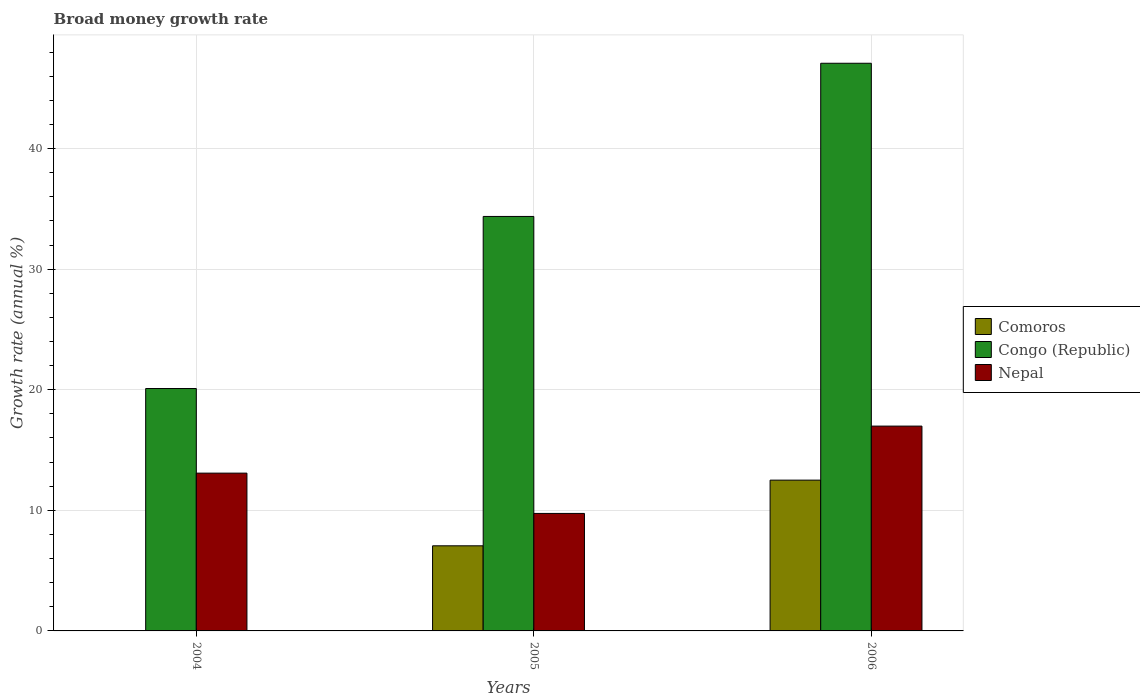Are the number of bars per tick equal to the number of legend labels?
Your answer should be very brief. No. In how many cases, is the number of bars for a given year not equal to the number of legend labels?
Your answer should be very brief. 1. Across all years, what is the maximum growth rate in Nepal?
Keep it short and to the point. 16.99. Across all years, what is the minimum growth rate in Nepal?
Provide a succinct answer. 9.74. What is the total growth rate in Congo (Republic) in the graph?
Offer a very short reply. 101.55. What is the difference between the growth rate in Nepal in 2005 and that in 2006?
Your response must be concise. -7.24. What is the difference between the growth rate in Nepal in 2005 and the growth rate in Congo (Republic) in 2004?
Ensure brevity in your answer.  -10.36. What is the average growth rate in Nepal per year?
Provide a short and direct response. 13.27. In the year 2006, what is the difference between the growth rate in Comoros and growth rate in Nepal?
Provide a short and direct response. -4.48. In how many years, is the growth rate in Nepal greater than 24 %?
Your answer should be very brief. 0. What is the ratio of the growth rate in Congo (Republic) in 2004 to that in 2005?
Ensure brevity in your answer.  0.58. Is the growth rate in Congo (Republic) in 2004 less than that in 2006?
Your answer should be very brief. Yes. What is the difference between the highest and the second highest growth rate in Nepal?
Give a very brief answer. 3.9. What is the difference between the highest and the lowest growth rate in Comoros?
Ensure brevity in your answer.  12.5. In how many years, is the growth rate in Congo (Republic) greater than the average growth rate in Congo (Republic) taken over all years?
Provide a short and direct response. 2. Is the sum of the growth rate in Congo (Republic) in 2004 and 2006 greater than the maximum growth rate in Nepal across all years?
Your answer should be very brief. Yes. How many bars are there?
Offer a very short reply. 8. Are all the bars in the graph horizontal?
Your answer should be compact. No. What is the difference between two consecutive major ticks on the Y-axis?
Your answer should be very brief. 10. Where does the legend appear in the graph?
Offer a terse response. Center right. What is the title of the graph?
Make the answer very short. Broad money growth rate. What is the label or title of the Y-axis?
Provide a short and direct response. Growth rate (annual %). What is the Growth rate (annual %) of Comoros in 2004?
Ensure brevity in your answer.  0. What is the Growth rate (annual %) of Congo (Republic) in 2004?
Your response must be concise. 20.1. What is the Growth rate (annual %) of Nepal in 2004?
Ensure brevity in your answer.  13.09. What is the Growth rate (annual %) of Comoros in 2005?
Make the answer very short. 7.06. What is the Growth rate (annual %) of Congo (Republic) in 2005?
Ensure brevity in your answer.  34.37. What is the Growth rate (annual %) in Nepal in 2005?
Give a very brief answer. 9.74. What is the Growth rate (annual %) of Comoros in 2006?
Make the answer very short. 12.5. What is the Growth rate (annual %) in Congo (Republic) in 2006?
Make the answer very short. 47.08. What is the Growth rate (annual %) of Nepal in 2006?
Make the answer very short. 16.99. Across all years, what is the maximum Growth rate (annual %) in Comoros?
Provide a short and direct response. 12.5. Across all years, what is the maximum Growth rate (annual %) of Congo (Republic)?
Provide a succinct answer. 47.08. Across all years, what is the maximum Growth rate (annual %) in Nepal?
Give a very brief answer. 16.99. Across all years, what is the minimum Growth rate (annual %) of Comoros?
Give a very brief answer. 0. Across all years, what is the minimum Growth rate (annual %) in Congo (Republic)?
Ensure brevity in your answer.  20.1. Across all years, what is the minimum Growth rate (annual %) of Nepal?
Your answer should be very brief. 9.74. What is the total Growth rate (annual %) of Comoros in the graph?
Make the answer very short. 19.56. What is the total Growth rate (annual %) of Congo (Republic) in the graph?
Your response must be concise. 101.55. What is the total Growth rate (annual %) of Nepal in the graph?
Keep it short and to the point. 39.81. What is the difference between the Growth rate (annual %) in Congo (Republic) in 2004 and that in 2005?
Your answer should be compact. -14.27. What is the difference between the Growth rate (annual %) in Nepal in 2004 and that in 2005?
Offer a terse response. 3.34. What is the difference between the Growth rate (annual %) in Congo (Republic) in 2004 and that in 2006?
Make the answer very short. -26.97. What is the difference between the Growth rate (annual %) in Nepal in 2004 and that in 2006?
Your answer should be very brief. -3.9. What is the difference between the Growth rate (annual %) of Comoros in 2005 and that in 2006?
Provide a short and direct response. -5.45. What is the difference between the Growth rate (annual %) in Congo (Republic) in 2005 and that in 2006?
Your answer should be compact. -12.7. What is the difference between the Growth rate (annual %) in Nepal in 2005 and that in 2006?
Ensure brevity in your answer.  -7.24. What is the difference between the Growth rate (annual %) of Congo (Republic) in 2004 and the Growth rate (annual %) of Nepal in 2005?
Offer a very short reply. 10.36. What is the difference between the Growth rate (annual %) of Congo (Republic) in 2004 and the Growth rate (annual %) of Nepal in 2006?
Your answer should be compact. 3.12. What is the difference between the Growth rate (annual %) of Comoros in 2005 and the Growth rate (annual %) of Congo (Republic) in 2006?
Offer a very short reply. -40.02. What is the difference between the Growth rate (annual %) in Comoros in 2005 and the Growth rate (annual %) in Nepal in 2006?
Give a very brief answer. -9.93. What is the difference between the Growth rate (annual %) in Congo (Republic) in 2005 and the Growth rate (annual %) in Nepal in 2006?
Ensure brevity in your answer.  17.39. What is the average Growth rate (annual %) of Comoros per year?
Your response must be concise. 6.52. What is the average Growth rate (annual %) of Congo (Republic) per year?
Keep it short and to the point. 33.85. What is the average Growth rate (annual %) in Nepal per year?
Offer a very short reply. 13.27. In the year 2004, what is the difference between the Growth rate (annual %) of Congo (Republic) and Growth rate (annual %) of Nepal?
Make the answer very short. 7.02. In the year 2005, what is the difference between the Growth rate (annual %) of Comoros and Growth rate (annual %) of Congo (Republic)?
Your response must be concise. -27.31. In the year 2005, what is the difference between the Growth rate (annual %) of Comoros and Growth rate (annual %) of Nepal?
Ensure brevity in your answer.  -2.69. In the year 2005, what is the difference between the Growth rate (annual %) of Congo (Republic) and Growth rate (annual %) of Nepal?
Ensure brevity in your answer.  24.63. In the year 2006, what is the difference between the Growth rate (annual %) in Comoros and Growth rate (annual %) in Congo (Republic)?
Your response must be concise. -34.57. In the year 2006, what is the difference between the Growth rate (annual %) of Comoros and Growth rate (annual %) of Nepal?
Keep it short and to the point. -4.48. In the year 2006, what is the difference between the Growth rate (annual %) in Congo (Republic) and Growth rate (annual %) in Nepal?
Offer a very short reply. 30.09. What is the ratio of the Growth rate (annual %) in Congo (Republic) in 2004 to that in 2005?
Provide a short and direct response. 0.58. What is the ratio of the Growth rate (annual %) of Nepal in 2004 to that in 2005?
Keep it short and to the point. 1.34. What is the ratio of the Growth rate (annual %) in Congo (Republic) in 2004 to that in 2006?
Give a very brief answer. 0.43. What is the ratio of the Growth rate (annual %) in Nepal in 2004 to that in 2006?
Your answer should be compact. 0.77. What is the ratio of the Growth rate (annual %) in Comoros in 2005 to that in 2006?
Ensure brevity in your answer.  0.56. What is the ratio of the Growth rate (annual %) of Congo (Republic) in 2005 to that in 2006?
Make the answer very short. 0.73. What is the ratio of the Growth rate (annual %) in Nepal in 2005 to that in 2006?
Offer a terse response. 0.57. What is the difference between the highest and the second highest Growth rate (annual %) of Congo (Republic)?
Your answer should be very brief. 12.7. What is the difference between the highest and the second highest Growth rate (annual %) of Nepal?
Provide a succinct answer. 3.9. What is the difference between the highest and the lowest Growth rate (annual %) of Comoros?
Your response must be concise. 12.5. What is the difference between the highest and the lowest Growth rate (annual %) of Congo (Republic)?
Offer a terse response. 26.97. What is the difference between the highest and the lowest Growth rate (annual %) of Nepal?
Make the answer very short. 7.24. 